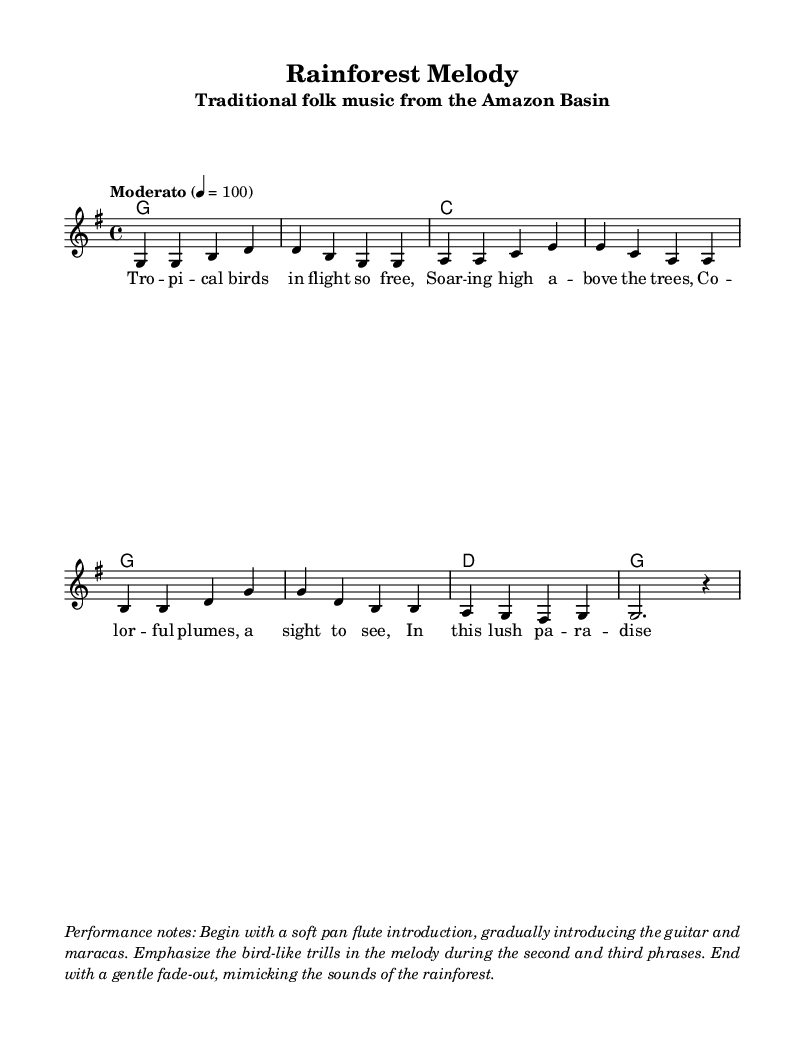What is the tempo of the piece? The tempo is indicated as "Moderato" with a metronome marking of 4 = 100, which denotes a moderate, steady pace.
Answer: Moderato, 4 = 100 What is the time signature of this music? The time signature is found in the beginning of the score, indicated as 4/4, which means there are four beats per measure, and the quarter note gets one beat.
Answer: 4/4 How many measures are in the melody? By counting the groups of notes separated by vertical lines (bar lines) in the melody, there are a total of eight measures presented in the piece.
Answer: Eight What key is the music composed in? The key signature at the beginning indicates that the piece is in G major, as there are one sharp (F#) noted in the key signature.
Answer: G major What instruments are suggested for performance? The performance notes mention using a soft pan flute, guitar, and maracas, indicating traditional accompaniment for folk music in tropical settings.
Answer: Pan flute, guitar, maracas What theme is reflected in the lyrics? The lyrics express the beauty and freedom of tropical birds and the lush environment, capturing the essence of tropical paradise.
Answer: Tropical birds Which phrases in the melody should have emphasized bird-like trills? The performance notes specifically advise focusing on the bird-like trills during the second and third phrases of the melody, highlighting their importance in the interpretation.
Answer: Second and third phrases 